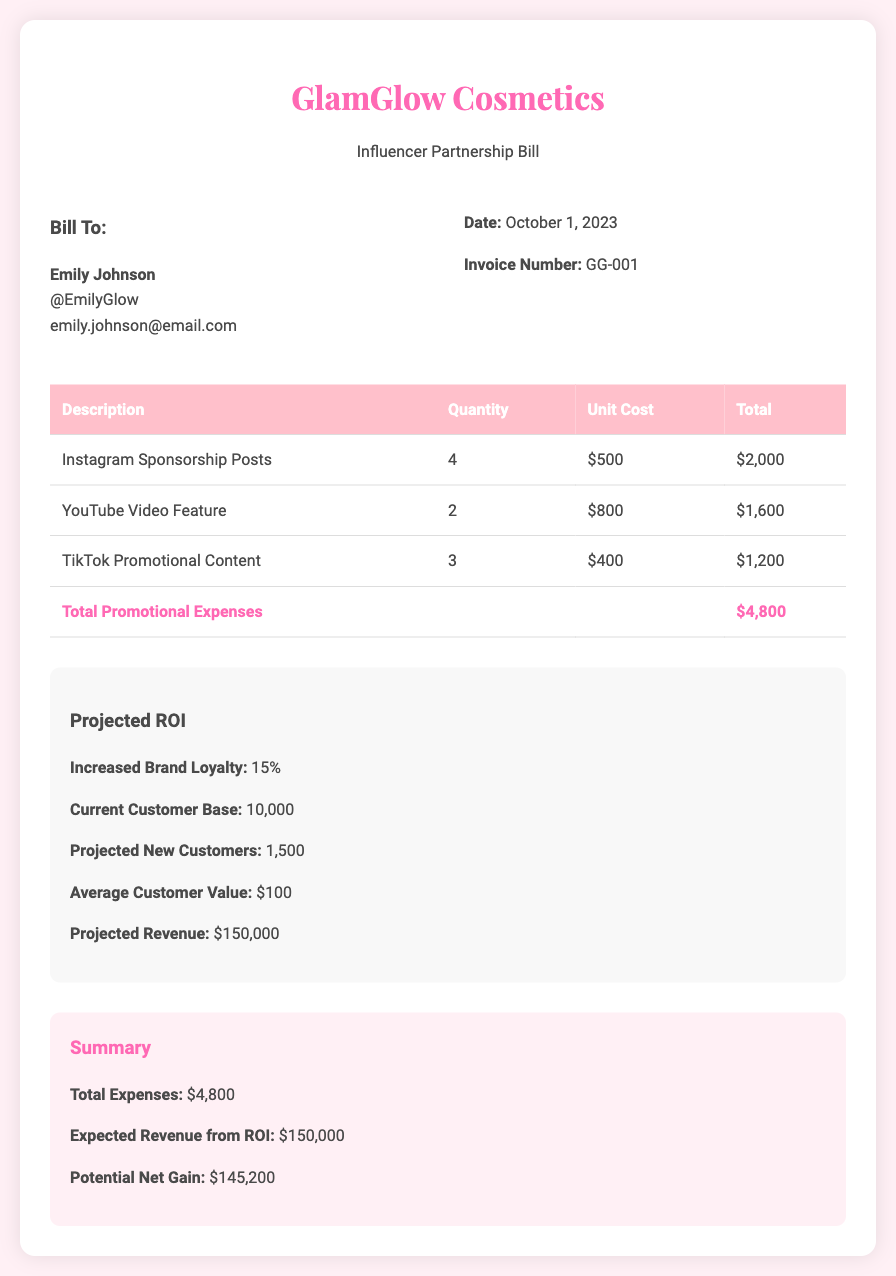what is the invoice number? The invoice number is listed under bill details in the document.
Answer: GG-001 who is the bill addressed to? The bill is directed to the name and email provided in the bill to section.
Answer: Emily Johnson what is the total promotional expenses? The total promotional expenses are calculated from the table of costs in the document.
Answer: $4,800 how many Instagram sponsorship posts are included? The quantity of Instagram sponsorship posts is specified in the table.
Answer: 4 what is the average customer value mentioned in the document? The average customer value is explicitly stated in the projected ROI section.
Answer: $100 what is the projected revenue from increased brand loyalty? The projected revenue is derived from the customer base and average customer value in the projected ROI section.
Answer: $150,000 what is the increase in brand loyalty percentage? The increase in brand loyalty is clearly stated in the projected ROI section of the document.
Answer: 15% what is the potential net gain calculated from the expenses? The potential net gain is calculated based on total expenses and expected revenue, detailed in the summary section.
Answer: $145,200 how many projected new customers are expected? The number of projected new customers is mentioned in the projected ROI section.
Answer: 1,500 